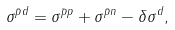Convert formula to latex. <formula><loc_0><loc_0><loc_500><loc_500>\sigma ^ { \bar { p } d } = \sigma ^ { \bar { p } p } + \sigma ^ { \bar { p } n } - \delta \sigma ^ { d } ,</formula> 